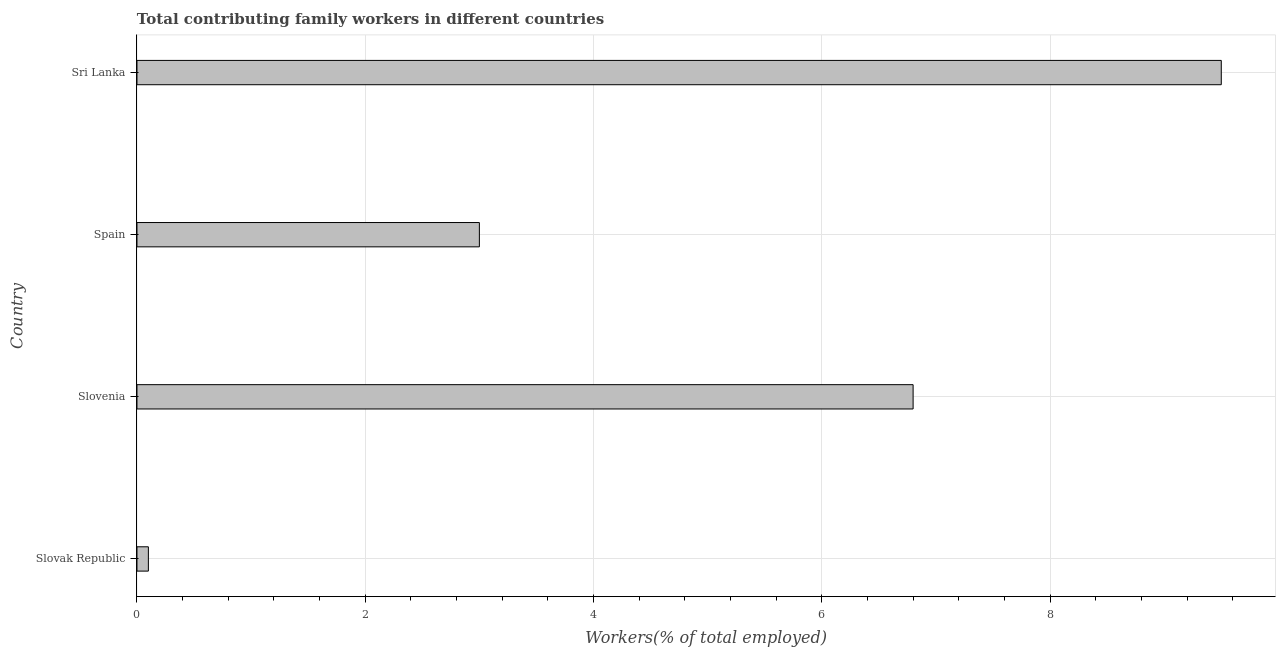Does the graph contain any zero values?
Make the answer very short. No. Does the graph contain grids?
Ensure brevity in your answer.  Yes. What is the title of the graph?
Offer a very short reply. Total contributing family workers in different countries. What is the label or title of the X-axis?
Provide a short and direct response. Workers(% of total employed). What is the contributing family workers in Slovak Republic?
Provide a succinct answer. 0.1. Across all countries, what is the minimum contributing family workers?
Your response must be concise. 0.1. In which country was the contributing family workers maximum?
Your response must be concise. Sri Lanka. In which country was the contributing family workers minimum?
Ensure brevity in your answer.  Slovak Republic. What is the sum of the contributing family workers?
Provide a short and direct response. 19.4. What is the average contributing family workers per country?
Provide a short and direct response. 4.85. What is the median contributing family workers?
Provide a short and direct response. 4.9. In how many countries, is the contributing family workers greater than 8 %?
Give a very brief answer. 1. What is the ratio of the contributing family workers in Slovenia to that in Spain?
Give a very brief answer. 2.27. Is the contributing family workers in Slovak Republic less than that in Slovenia?
Offer a very short reply. Yes. Are all the bars in the graph horizontal?
Your response must be concise. Yes. How many countries are there in the graph?
Provide a succinct answer. 4. Are the values on the major ticks of X-axis written in scientific E-notation?
Keep it short and to the point. No. What is the Workers(% of total employed) in Slovak Republic?
Your response must be concise. 0.1. What is the Workers(% of total employed) in Slovenia?
Your answer should be very brief. 6.8. What is the Workers(% of total employed) in Sri Lanka?
Your response must be concise. 9.5. What is the difference between the Workers(% of total employed) in Slovak Republic and Slovenia?
Make the answer very short. -6.7. What is the difference between the Workers(% of total employed) in Slovak Republic and Sri Lanka?
Your answer should be compact. -9.4. What is the difference between the Workers(% of total employed) in Slovenia and Spain?
Your response must be concise. 3.8. What is the difference between the Workers(% of total employed) in Slovenia and Sri Lanka?
Offer a very short reply. -2.7. What is the ratio of the Workers(% of total employed) in Slovak Republic to that in Slovenia?
Offer a terse response. 0.01. What is the ratio of the Workers(% of total employed) in Slovak Republic to that in Spain?
Offer a terse response. 0.03. What is the ratio of the Workers(% of total employed) in Slovak Republic to that in Sri Lanka?
Provide a succinct answer. 0.01. What is the ratio of the Workers(% of total employed) in Slovenia to that in Spain?
Your answer should be very brief. 2.27. What is the ratio of the Workers(% of total employed) in Slovenia to that in Sri Lanka?
Offer a very short reply. 0.72. What is the ratio of the Workers(% of total employed) in Spain to that in Sri Lanka?
Provide a short and direct response. 0.32. 